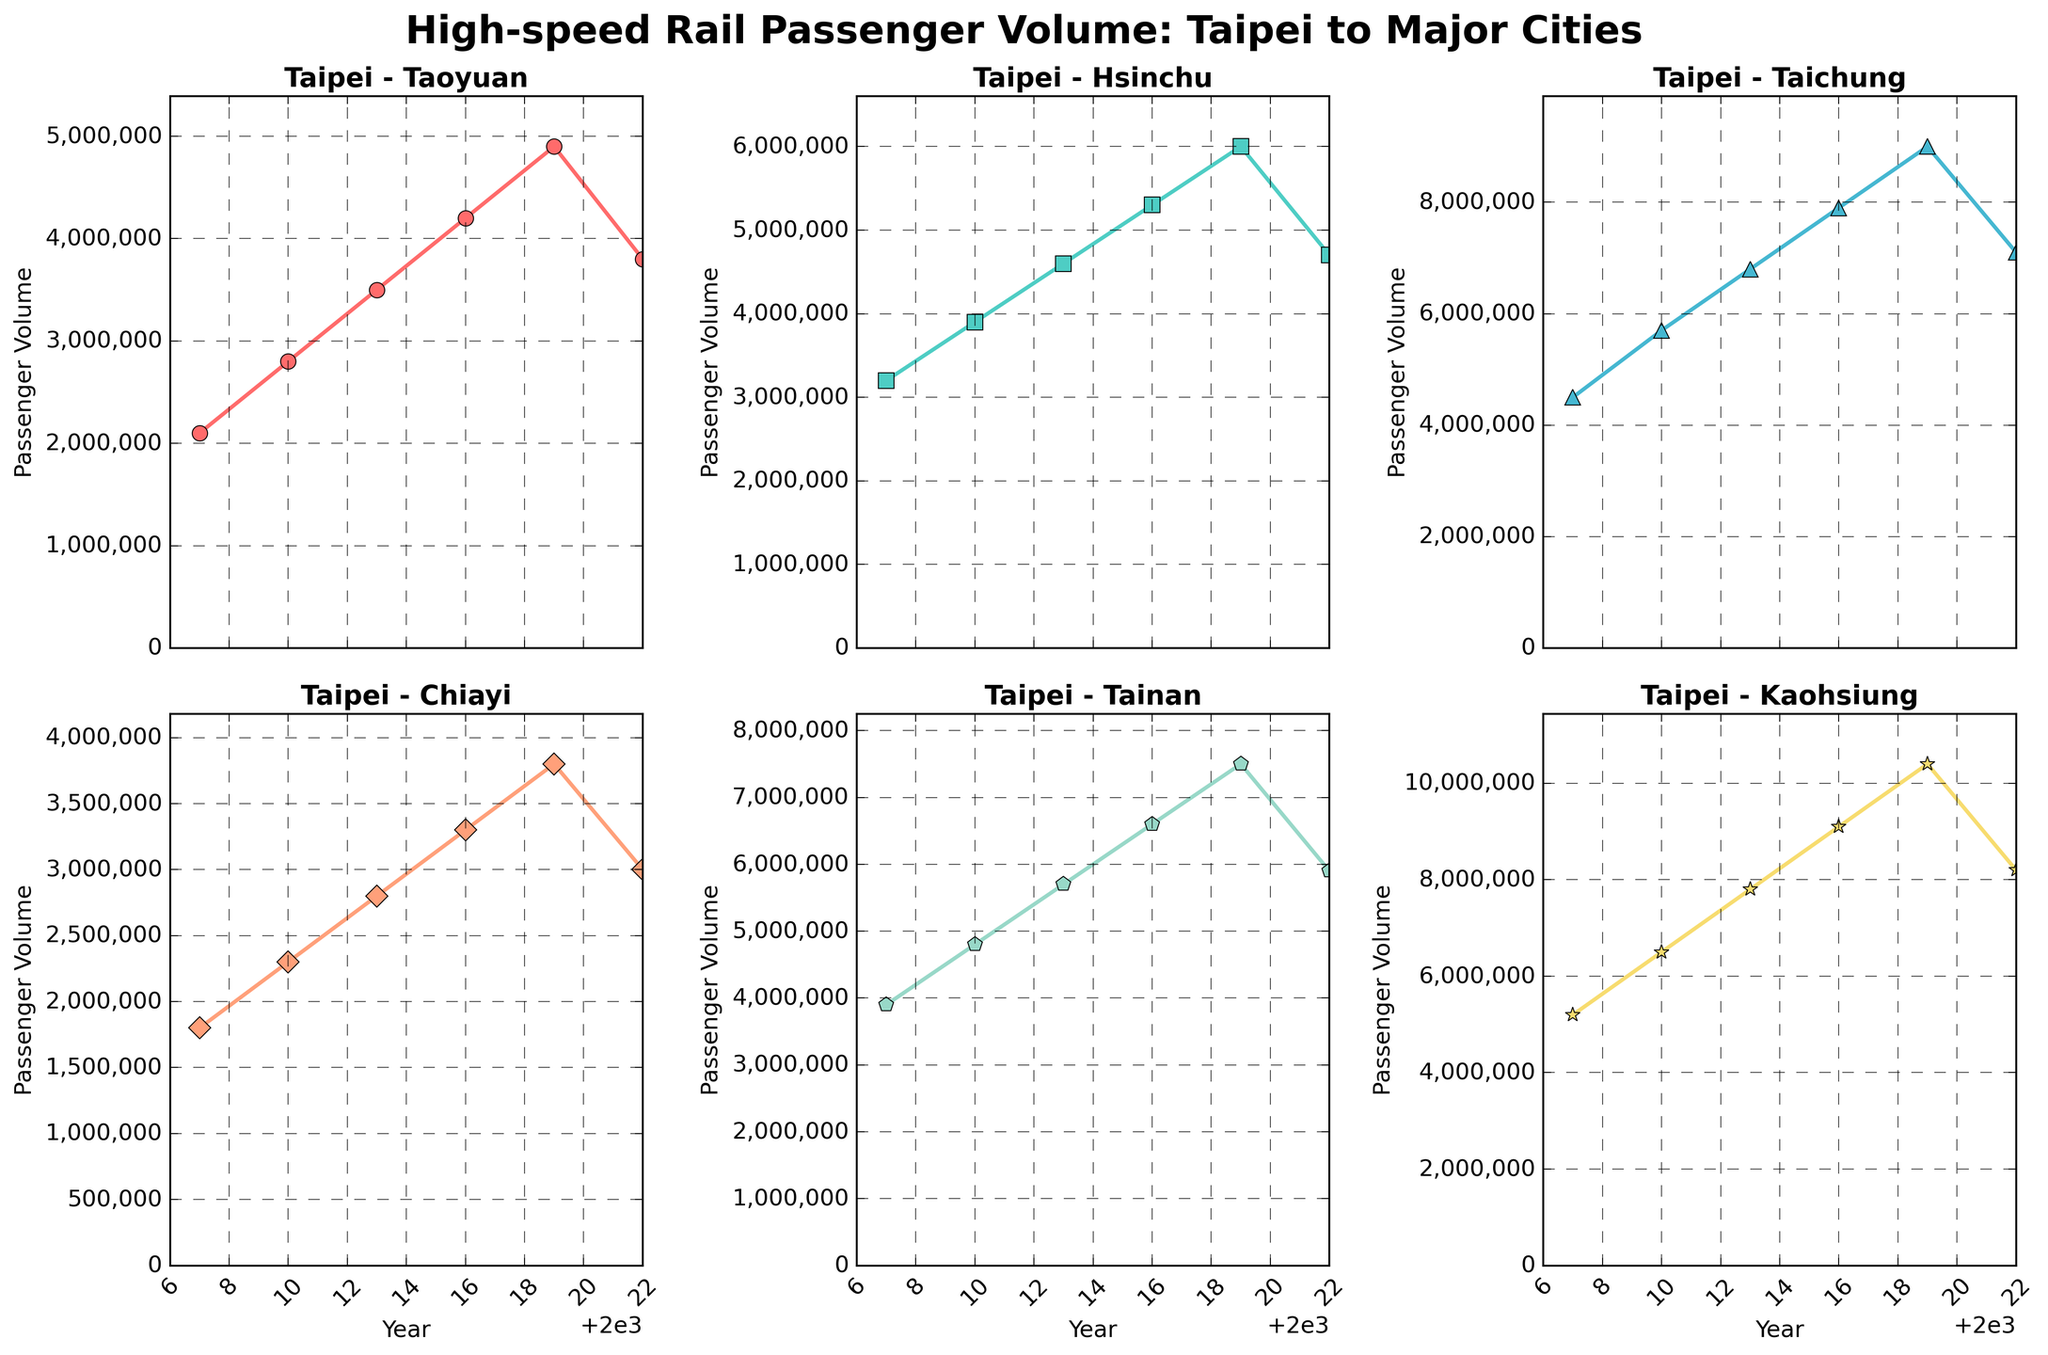What is the title of the figure? The title of the figure is displayed at the top and reads "High-speed Rail Passenger Volume: Taipei to Major Cities".
Answer: High-speed Rail Passenger Volume: Taipei to Major Cities How many subplots are shown in the figure? The figure consists of six subplots arranged in a 2x3 grid.
Answer: Six Which route has the highest passenger volume in 2007? By examining the 2007 data point across all subplots, the route from Taipei to Kaohsiung has the highest passenger volume.
Answer: Taipei-Kaohsiung What is the passenger volume for the Taipei-Taichung route in 2019? The subplot titled "Taipei - Taichung" shows the passenger volume in 2019, which is 9,000,000.
Answer: 9,000,000 What is the trend of passenger volume on the Taipei-Tainan route from 2019 to 2022? The subplot titled "Taipei - Tainan" shows a decreasing trend from 7,500,000 in 2019 to 5,900,000 in 2022.
Answer: Decreasing Which city shows a decrease in passenger volume from 2019 to 2022? By comparing the 2019 and 2022 data points, all the subplots show a decrease in passenger volume during this period. However, the volume decrease from Taipei to Kaohsiung is the most pronounced.
Answer: All major cities What was the average passenger volume of the Taipei-Hsinchu route from 2007 to 2019? The passenger volumes for the years 2007, 2010, 2013, 2016, and 2019 are 3,200,000, 3,900,000, 4,600,000, 5,300,000, and 6,000,000 respectively. The average is calculated as (3,200,000 + 3,900,000 + 4,600,000 + 5,300,000 + 6,000,000) / 5 = 4,600,000.
Answer: 4,600,000 Which route had the smallest passenger volume in 2016? The subplot for "Taipei - Chiayi" shows that 3,300,000 is the smallest passenger volume in 2016 compared to other routes.
Answer: Taipei-Chiayi How does the growth pattern of the Taipei-Taoyuan route compare to the Taipei-Kaohsiung route from 2010 to 2019? By examining the subplots, both routes show an increasing trend, but the Taipei-Kaohsiung route grows at a faster rate, not only starting higher but also ending higher.
Answer: Faster growth for Taipei-Kaohsiung What is the percentage increase in passenger volume for the Taipei-Tainan route from 2007 to 2019? Initially, in 2007, the volume was 3,900,000, and in 2019, it was 7,500,000. The percentage increase is calculated as ((7,500,000 - 3,900,000) / 3,900,000) * 100 ≈ 92.31%.
Answer: 92.31% What is the pattern of change in the passenger volume of the Taipei-Chiayi route from 2007 to 2022? The subplot for "Taipei - Chiayi" indicates a general upward trend from 2007 to 2019, followed by a decrease by 2022.
Answer: Increase until 2019, then decrease 